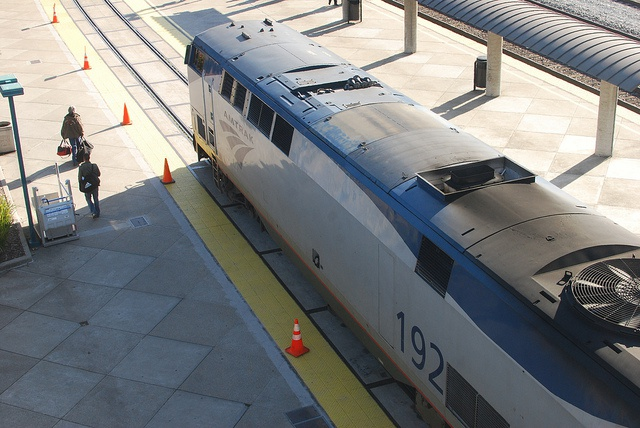Describe the objects in this image and their specific colors. I can see train in beige, gray, black, darkgray, and navy tones, people in beige, black, gray, and ivory tones, people in beige, black, and gray tones, backpack in beige, black, and gray tones, and handbag in beige, black, maroon, ivory, and brown tones in this image. 